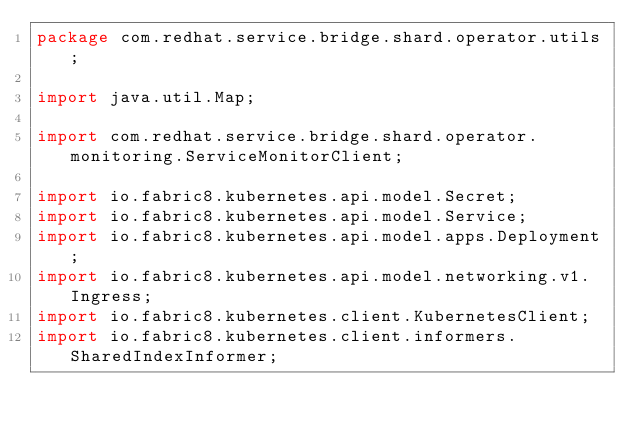Convert code to text. <code><loc_0><loc_0><loc_500><loc_500><_Java_>package com.redhat.service.bridge.shard.operator.utils;

import java.util.Map;

import com.redhat.service.bridge.shard.operator.monitoring.ServiceMonitorClient;

import io.fabric8.kubernetes.api.model.Secret;
import io.fabric8.kubernetes.api.model.Service;
import io.fabric8.kubernetes.api.model.apps.Deployment;
import io.fabric8.kubernetes.api.model.networking.v1.Ingress;
import io.fabric8.kubernetes.client.KubernetesClient;
import io.fabric8.kubernetes.client.informers.SharedIndexInformer;</code> 